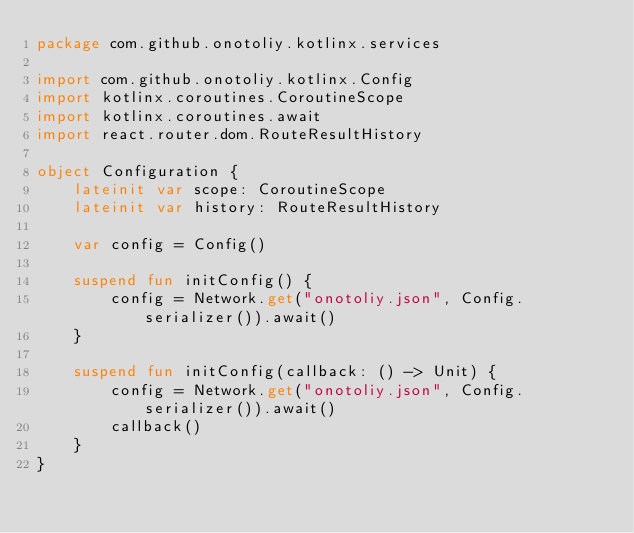<code> <loc_0><loc_0><loc_500><loc_500><_Kotlin_>package com.github.onotoliy.kotlinx.services

import com.github.onotoliy.kotlinx.Config
import kotlinx.coroutines.CoroutineScope
import kotlinx.coroutines.await
import react.router.dom.RouteResultHistory

object Configuration {
    lateinit var scope: CoroutineScope
    lateinit var history: RouteResultHistory

    var config = Config()

    suspend fun initConfig() {
        config = Network.get("onotoliy.json", Config.serializer()).await()
    }

    suspend fun initConfig(callback: () -> Unit) {
        config = Network.get("onotoliy.json", Config.serializer()).await()
        callback()
    }
}
</code> 